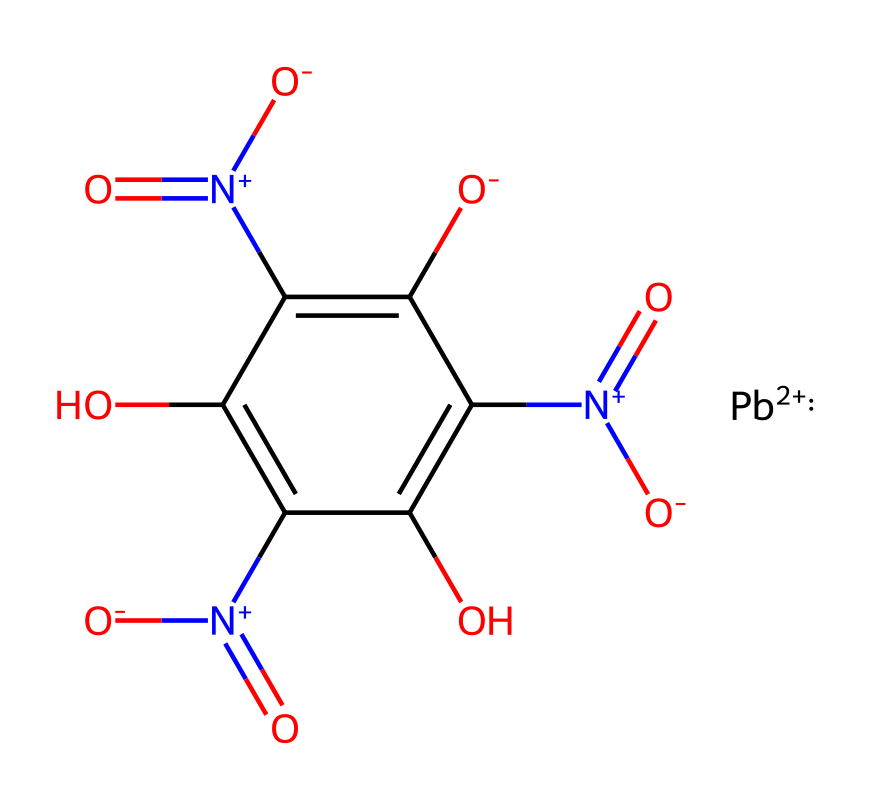what is the central metal atom in this compound? The chemical structure shows a lead ion represented by [Pb+2], which indicates that lead is the central metal atom present in this compound.
Answer: lead how many nitro groups are present in this structure? In the provided SMILES representation, there are three instances of [N+](=O)[O-], which indicates the presence of three nitro groups attached to the aromatic ring.
Answer: three what type of bonding is indicated between the lead and the other components? The lead ion ([Pb+2]) forms ionic bonding with the surrounding components, as it carries a positive charge and interacts with negatively charged species, such as the oxide or nitro groups.
Answer: ionic which functional groups are present in this chemical structure? The chemical structure contains nitro groups ([N+](=O)[O-]) and hydroxyl groups (c(O)), indicating both groups are present in this compound.
Answer: nitro and hydroxyl what overall charge does this molecule carry? The lead ion is [Pb+2], and while the nitro groups have a net negative charge, the presence of lead predominantly dictates the overall charge, resulting in a neutral molecule overall.
Answer: neutral 